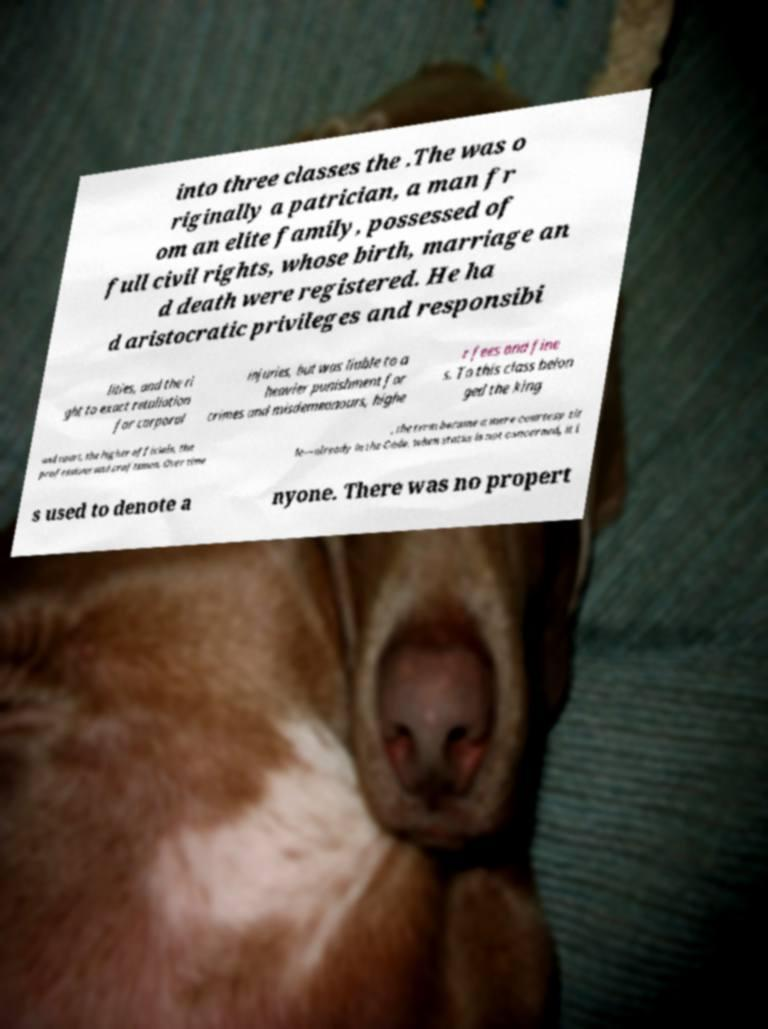Please identify and transcribe the text found in this image. into three classes the .The was o riginally a patrician, a man fr om an elite family, possessed of full civil rights, whose birth, marriage an d death were registered. He ha d aristocratic privileges and responsibi lities, and the ri ght to exact retaliation for corporal injuries, but was liable to a heavier punishment for crimes and misdemeanours, highe r fees and fine s. To this class belon ged the king and court, the higher officials, the professions and craftsmen. Over time , the term became a mere courtesy tit le—already in the Code, when status is not concerned, it i s used to denote a nyone. There was no propert 